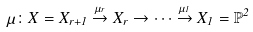<formula> <loc_0><loc_0><loc_500><loc_500>\mu \colon X = X _ { r + 1 } \stackrel { \mu _ { r } } { \rightarrow } X _ { r } \rightarrow \cdots \stackrel { \mu _ { 1 } } { \rightarrow } X _ { 1 } = \mathbb { P } ^ { 2 }</formula> 